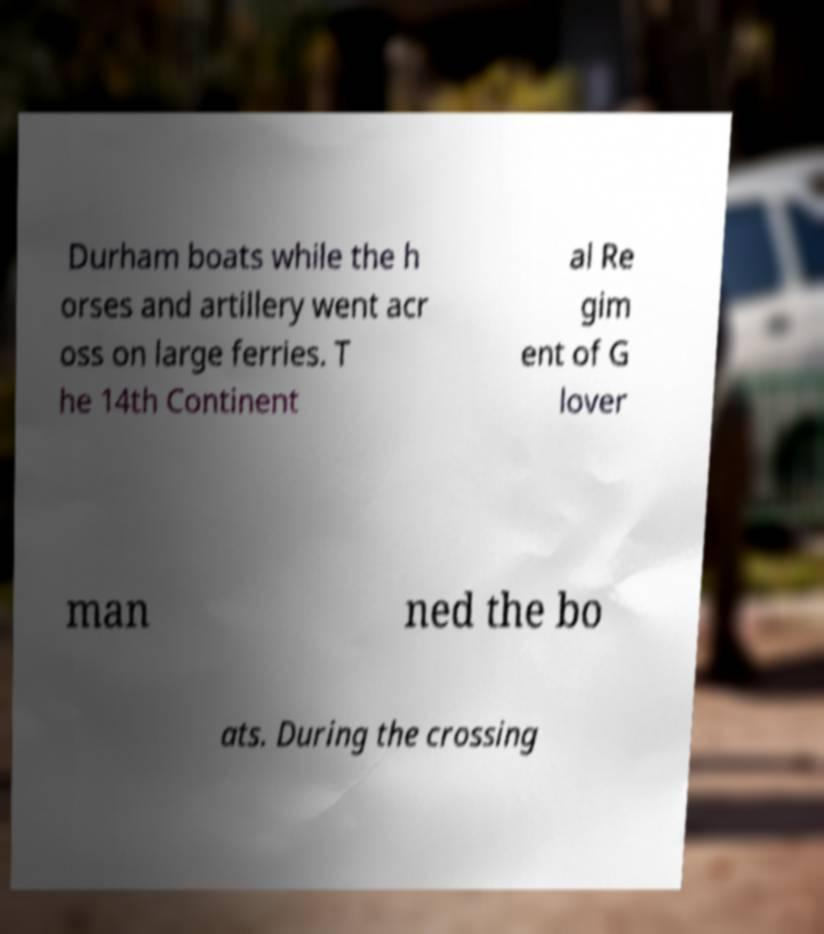I need the written content from this picture converted into text. Can you do that? Durham boats while the h orses and artillery went acr oss on large ferries. T he 14th Continent al Re gim ent of G lover man ned the bo ats. During the crossing 